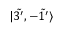<formula> <loc_0><loc_0><loc_500><loc_500>| \tilde { 3 ^ { \prime } } , - \tilde { 1 ^ { \prime } } \rangle</formula> 